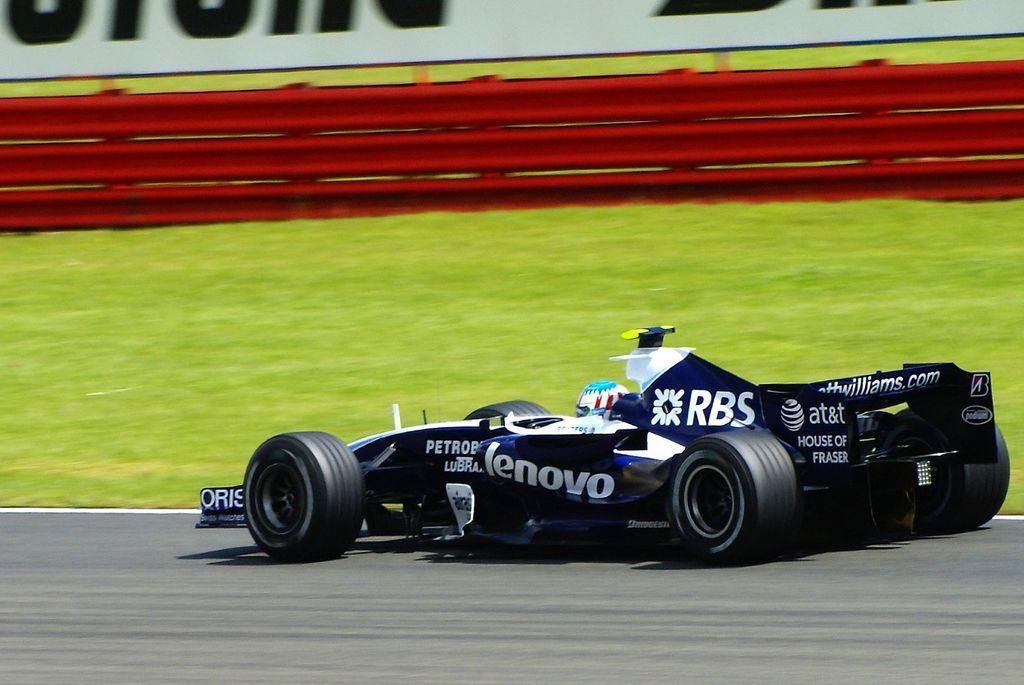Could you give a brief overview of what you see in this image? In this image we can see F1 car which is of black color moving on the track and in the background of the image we can see grass and red color fencing. 